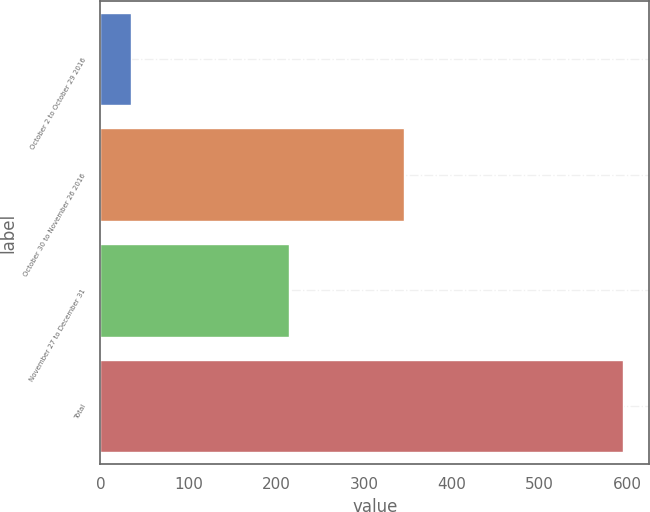<chart> <loc_0><loc_0><loc_500><loc_500><bar_chart><fcel>October 2 to October 29 2016<fcel>October 30 to November 26 2016<fcel>November 27 to December 31<fcel>Total<nl><fcel>35<fcel>345<fcel>215<fcel>595<nl></chart> 